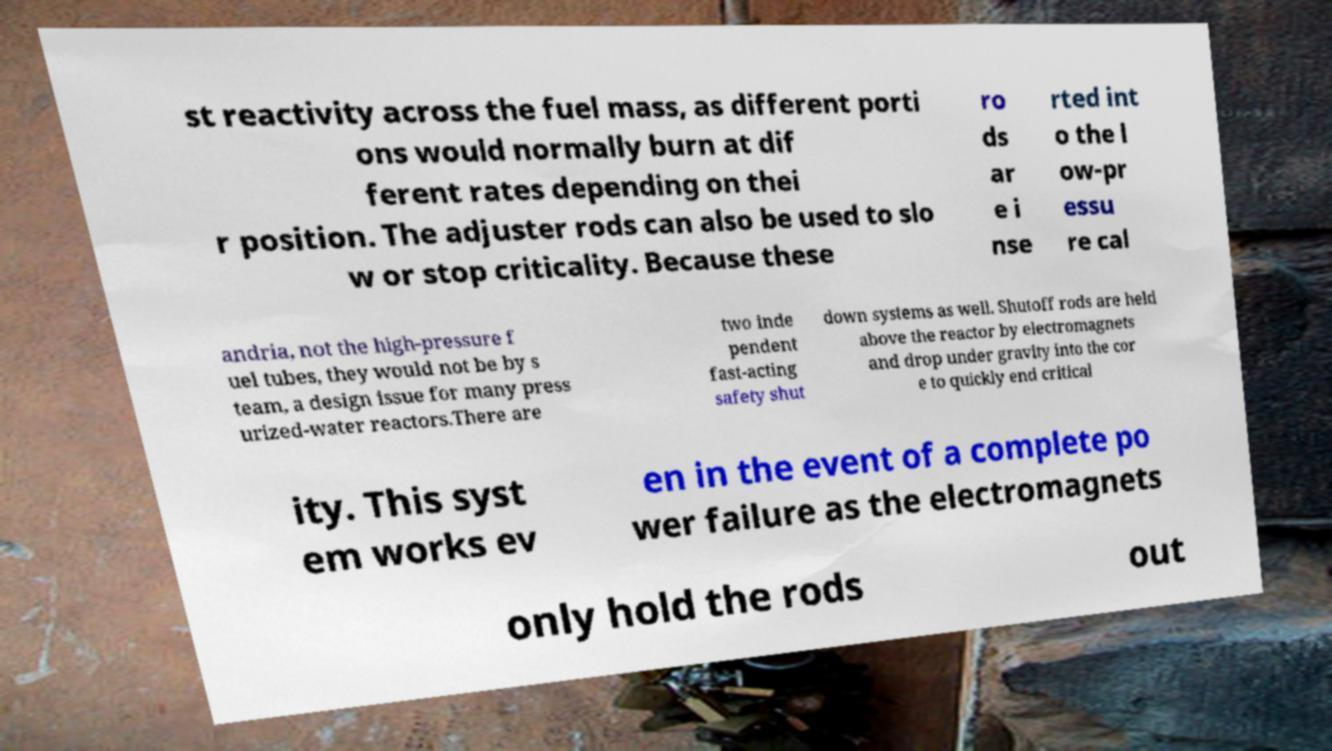Please identify and transcribe the text found in this image. st reactivity across the fuel mass, as different porti ons would normally burn at dif ferent rates depending on thei r position. The adjuster rods can also be used to slo w or stop criticality. Because these ro ds ar e i nse rted int o the l ow-pr essu re cal andria, not the high-pressure f uel tubes, they would not be by s team, a design issue for many press urized-water reactors.There are two inde pendent fast-acting safety shut down systems as well. Shutoff rods are held above the reactor by electromagnets and drop under gravity into the cor e to quickly end critical ity. This syst em works ev en in the event of a complete po wer failure as the electromagnets only hold the rods out 